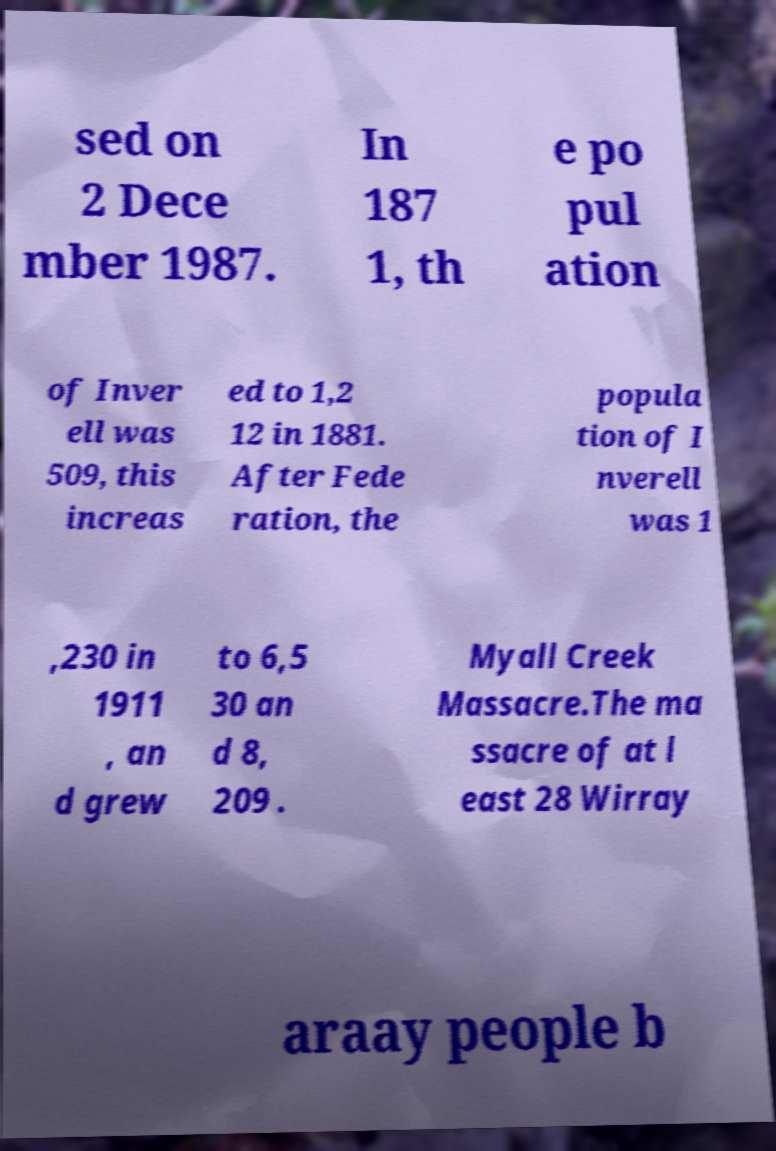Please identify and transcribe the text found in this image. sed on 2 Dece mber 1987. In 187 1, th e po pul ation of Inver ell was 509, this increas ed to 1,2 12 in 1881. After Fede ration, the popula tion of I nverell was 1 ,230 in 1911 , an d grew to 6,5 30 an d 8, 209 . Myall Creek Massacre.The ma ssacre of at l east 28 Wirray araay people b 